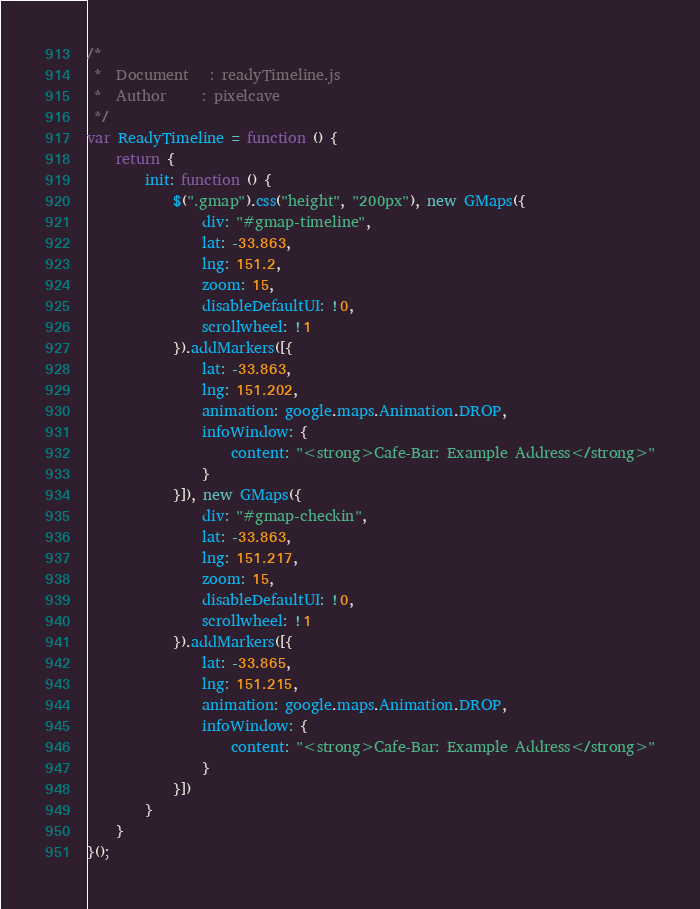Convert code to text. <code><loc_0><loc_0><loc_500><loc_500><_JavaScript_>/*
 *  Document   : readyTimeline.js
 *  Author     : pixelcave
 */
var ReadyTimeline = function () {
    return {
        init: function () {
            $(".gmap").css("height", "200px"), new GMaps({
                div: "#gmap-timeline",
                lat: -33.863,
                lng: 151.2,
                zoom: 15,
                disableDefaultUI: !0,
                scrollwheel: !1
            }).addMarkers([{
                lat: -33.863,
                lng: 151.202,
                animation: google.maps.Animation.DROP,
                infoWindow: {
                    content: "<strong>Cafe-Bar: Example Address</strong>"
                }
            }]), new GMaps({
                div: "#gmap-checkin",
                lat: -33.863,
                lng: 151.217,
                zoom: 15,
                disableDefaultUI: !0,
                scrollwheel: !1
            }).addMarkers([{
                lat: -33.865,
                lng: 151.215,
                animation: google.maps.Animation.DROP,
                infoWindow: {
                    content: "<strong>Cafe-Bar: Example Address</strong>"
                }
            }])
        }
    }
}();</code> 